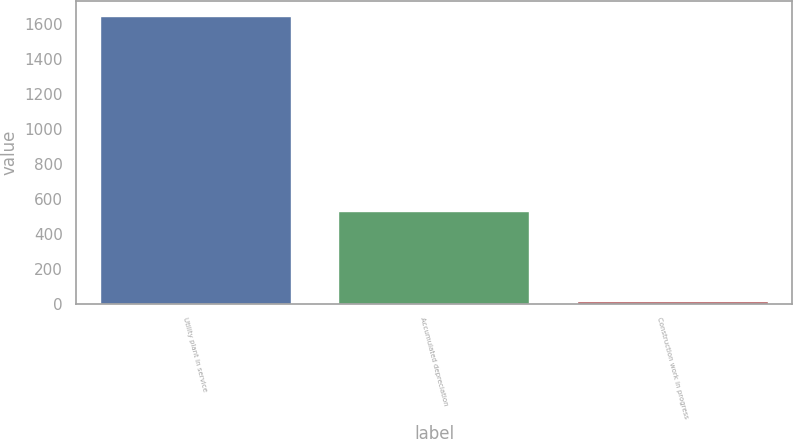<chart> <loc_0><loc_0><loc_500><loc_500><bar_chart><fcel>Utility plant in service<fcel>Accumulated depreciation<fcel>Construction work in progress<nl><fcel>1648<fcel>529<fcel>13<nl></chart> 